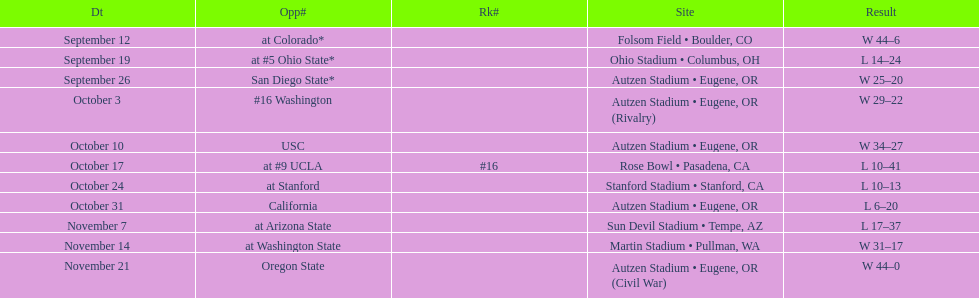Who was their last opponent of the season? Oregon State. 